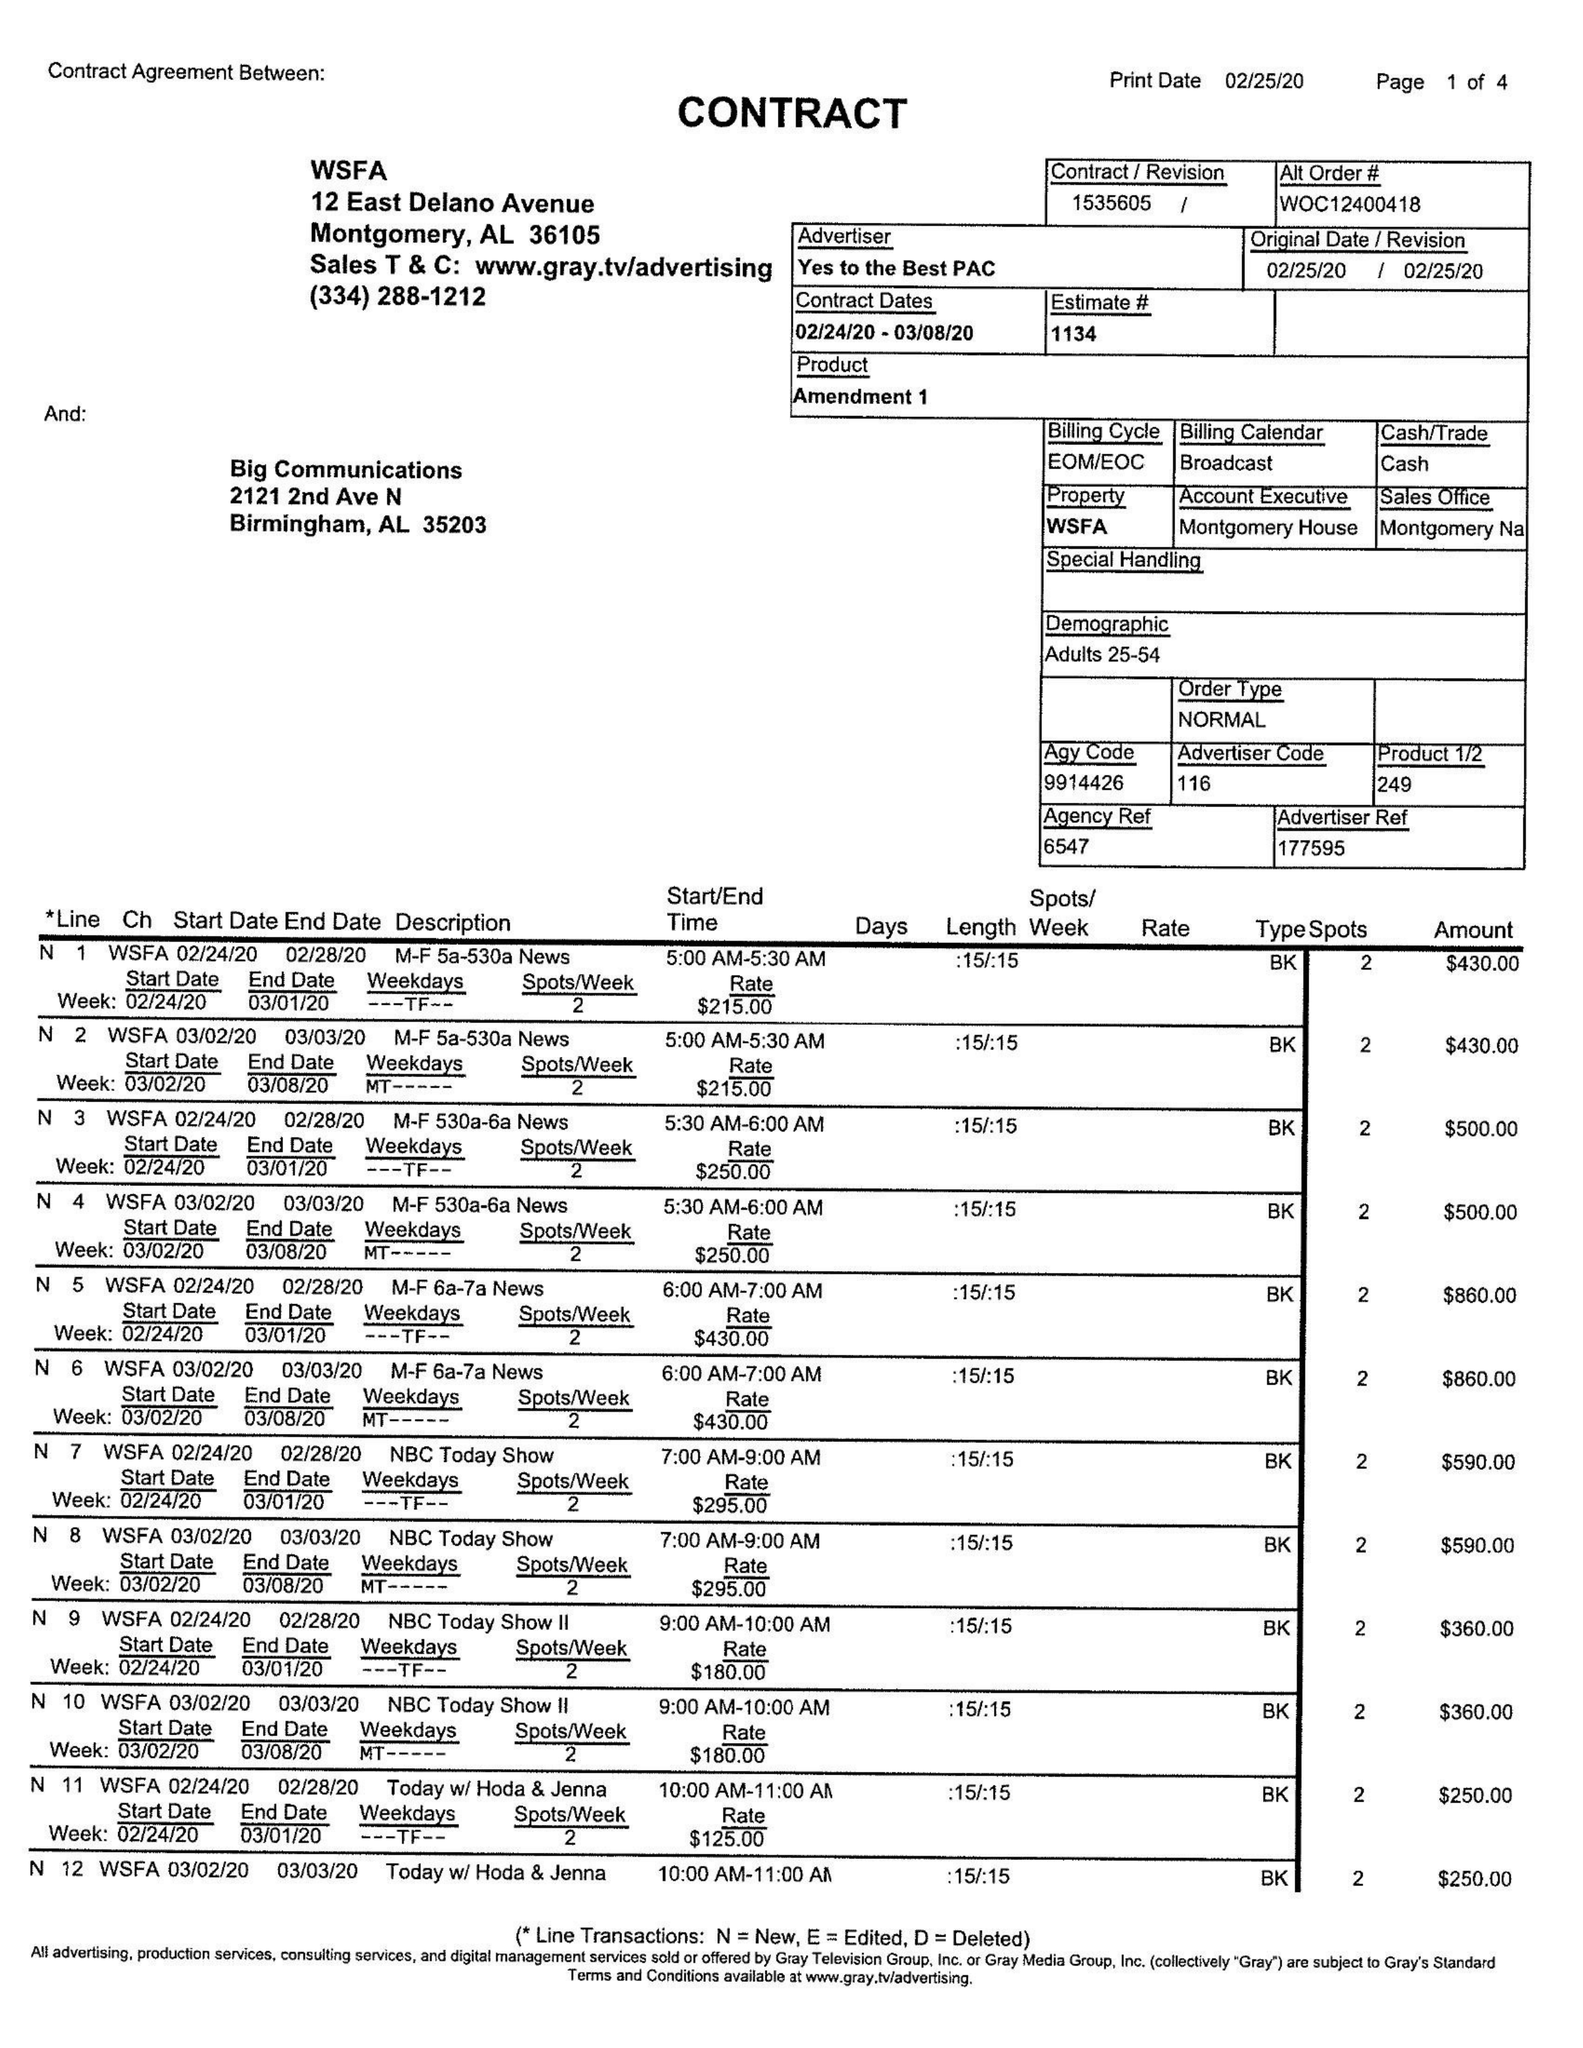What is the value for the gross_amount?
Answer the question using a single word or phrase. 21910.00 